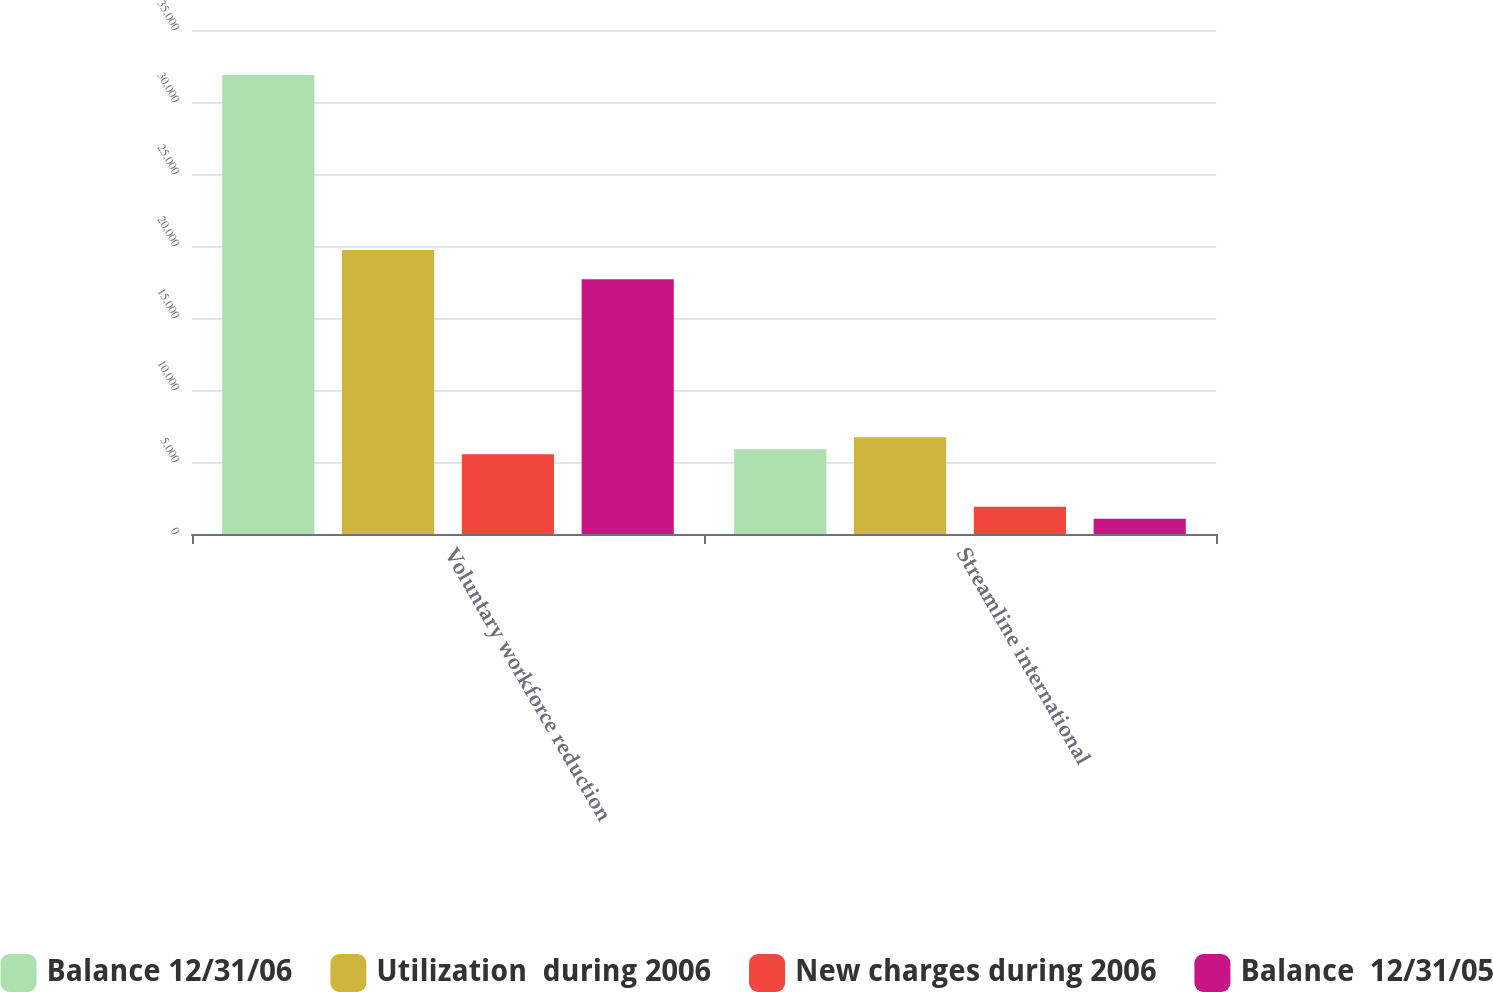<chart> <loc_0><loc_0><loc_500><loc_500><stacked_bar_chart><ecel><fcel>Voluntary workforce reduction<fcel>Streamline international<nl><fcel>Balance 12/31/06<fcel>31883<fcel>5888<nl><fcel>Utilization  during 2006<fcel>19727<fcel>6723<nl><fcel>New charges during 2006<fcel>5531<fcel>1896<nl><fcel>Balance  12/31/05<fcel>17687<fcel>1061<nl></chart> 